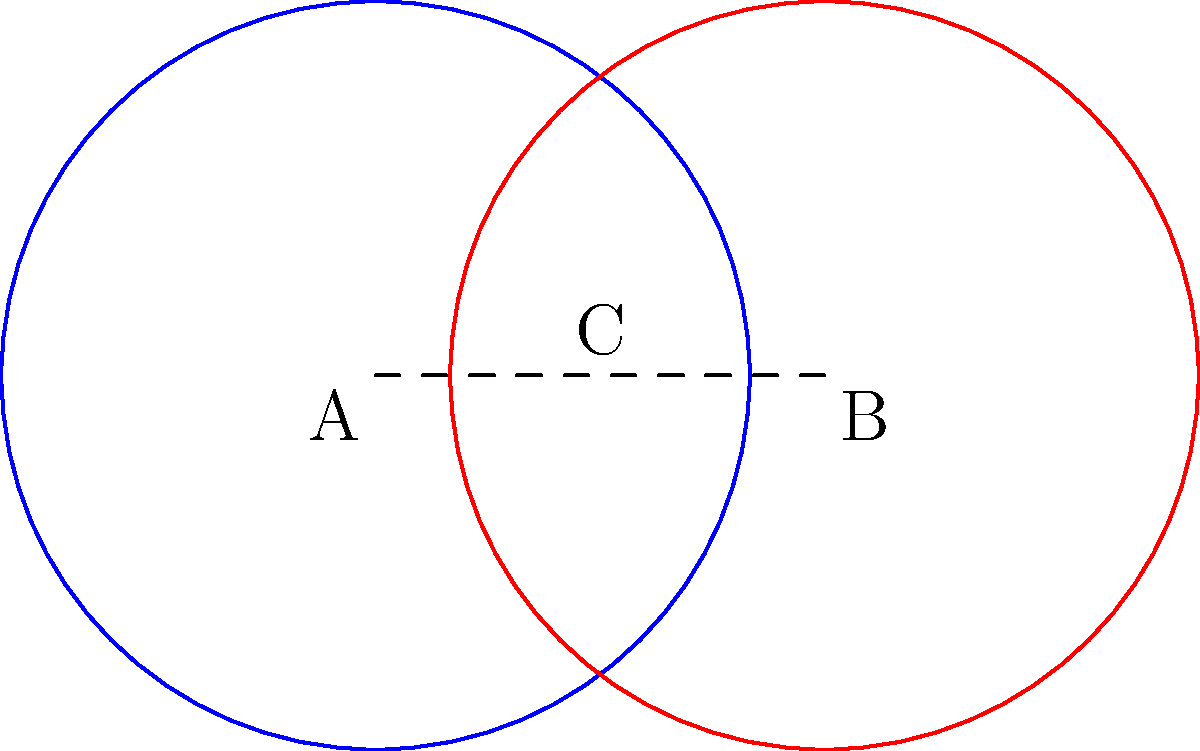In the diagram above, two circles represent different political ideologies in a two-party system. Circle A represents the ideology of Party A, and Circle B represents the ideology of Party B. The overlapping region C represents shared beliefs or policies. If each circle has a radius of 10 units, and the distance between their centers is 12 units, what percentage of the total area of both circles does the overlapping region represent? Round your answer to the nearest whole percent. To solve this problem, we'll follow these steps:

1) First, we need to calculate the area of one circle:
   Area of one circle = $\pi r^2 = \pi (10)^2 = 100\pi$ square units

2) The total area of both circles = $2 * 100\pi = 200\pi$ square units

3) To find the area of the overlapping region, we can use the formula for the area of the lens created by two intersecting circles:

   $A = 2r^2 \arccos(\frac{d}{2r}) - d\sqrt{r^2 - (\frac{d}{2})^2}$

   Where $r$ is the radius and $d$ is the distance between centers.

4) Plugging in our values:
   $A = 2(10)^2 \arccos(\frac{12}{2(10)}) - 12\sqrt{10^2 - (\frac{12}{2})^2}$
   $= 200 \arccos(0.6) - 12\sqrt{100 - 36}$
   $= 200 * 0.9273 - 12 * 8$
   $= 185.46 - 96$
   $= 89.46$ square units

5) To calculate the percentage, we divide the overlapping area by the total area and multiply by 100:

   Percentage = $\frac{89.46}{200\pi} * 100 \approx 14.23\%$

6) Rounding to the nearest whole percent gives us 14%.
Answer: 14% 